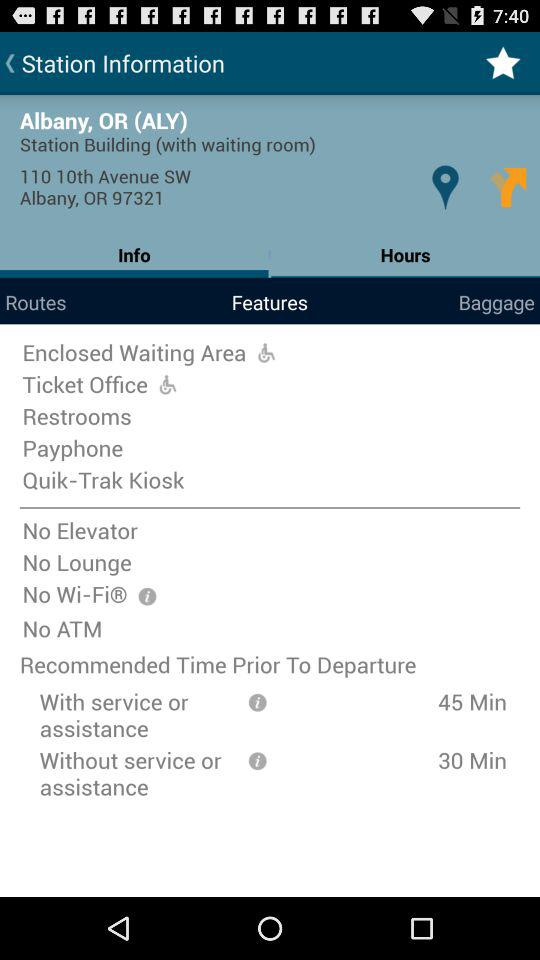What is the location? The location is 110 10th Avenue SW Albany, OR 97321. 